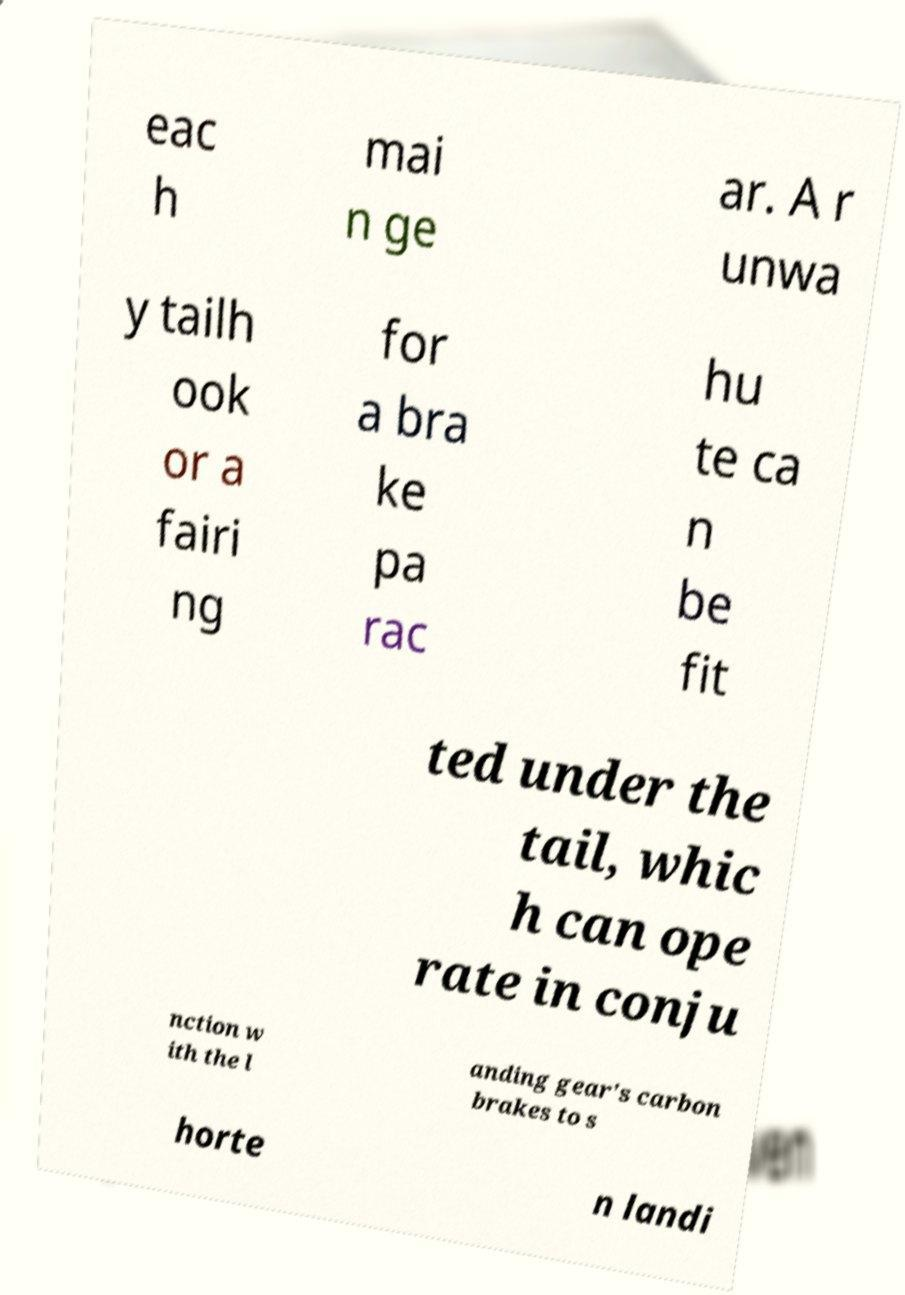Can you accurately transcribe the text from the provided image for me? eac h mai n ge ar. A r unwa y tailh ook or a fairi ng for a bra ke pa rac hu te ca n be fit ted under the tail, whic h can ope rate in conju nction w ith the l anding gear's carbon brakes to s horte n landi 